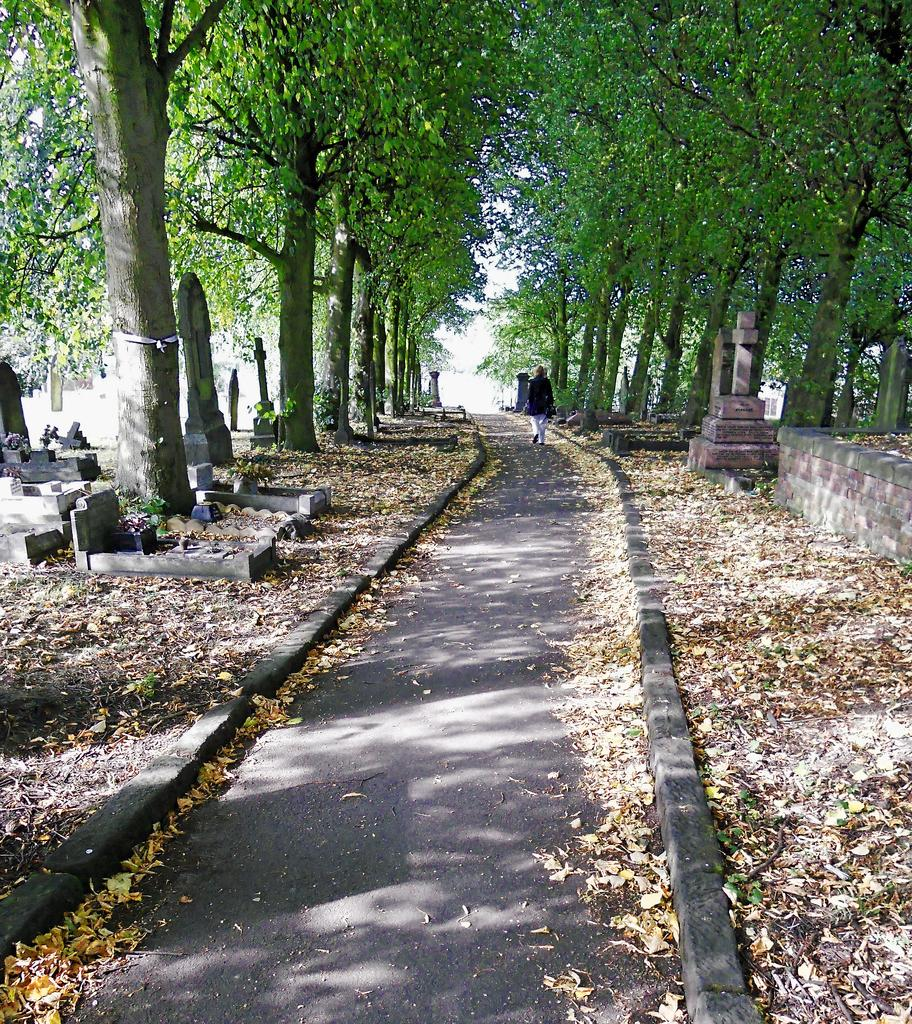What is the main setting of the image? The image depicts a graveyard. What can be seen in the middle of the graveyard? There is a path in the middle of the graveyard. What is present on the ground in the image? Leaves are present on the ground. Can you describe the person in the background? In the background, a person is walking on the path. What else can be seen in the background of the image? Trees and the sky are visible in the background. What type of ship can be seen sailing in the background of the image? There is no ship present in the image; it depicts a graveyard with a path, leaves, a person walking, trees, and the sky in the background. 